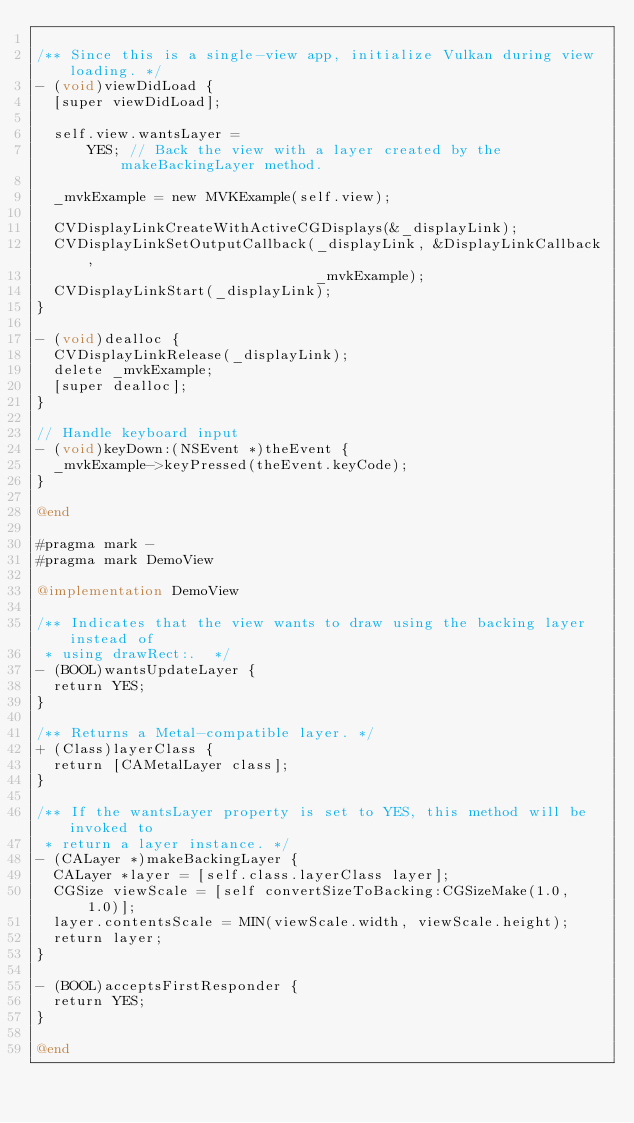<code> <loc_0><loc_0><loc_500><loc_500><_ObjectiveC_>
/** Since this is a single-view app, initialize Vulkan during view loading. */
- (void)viewDidLoad {
  [super viewDidLoad];

  self.view.wantsLayer =
      YES; // Back the view with a layer created by the makeBackingLayer method.

  _mvkExample = new MVKExample(self.view);

  CVDisplayLinkCreateWithActiveCGDisplays(&_displayLink);
  CVDisplayLinkSetOutputCallback(_displayLink, &DisplayLinkCallback,
                                 _mvkExample);
  CVDisplayLinkStart(_displayLink);
}

- (void)dealloc {
  CVDisplayLinkRelease(_displayLink);
  delete _mvkExample;
  [super dealloc];
}

// Handle keyboard input
- (void)keyDown:(NSEvent *)theEvent {
  _mvkExample->keyPressed(theEvent.keyCode);
}

@end

#pragma mark -
#pragma mark DemoView

@implementation DemoView

/** Indicates that the view wants to draw using the backing layer instead of
 * using drawRect:.  */
- (BOOL)wantsUpdateLayer {
  return YES;
}

/** Returns a Metal-compatible layer. */
+ (Class)layerClass {
  return [CAMetalLayer class];
}

/** If the wantsLayer property is set to YES, this method will be invoked to
 * return a layer instance. */
- (CALayer *)makeBackingLayer {
  CALayer *layer = [self.class.layerClass layer];
  CGSize viewScale = [self convertSizeToBacking:CGSizeMake(1.0, 1.0)];
  layer.contentsScale = MIN(viewScale.width, viewScale.height);
  return layer;
}

- (BOOL)acceptsFirstResponder {
  return YES;
}

@end
</code> 